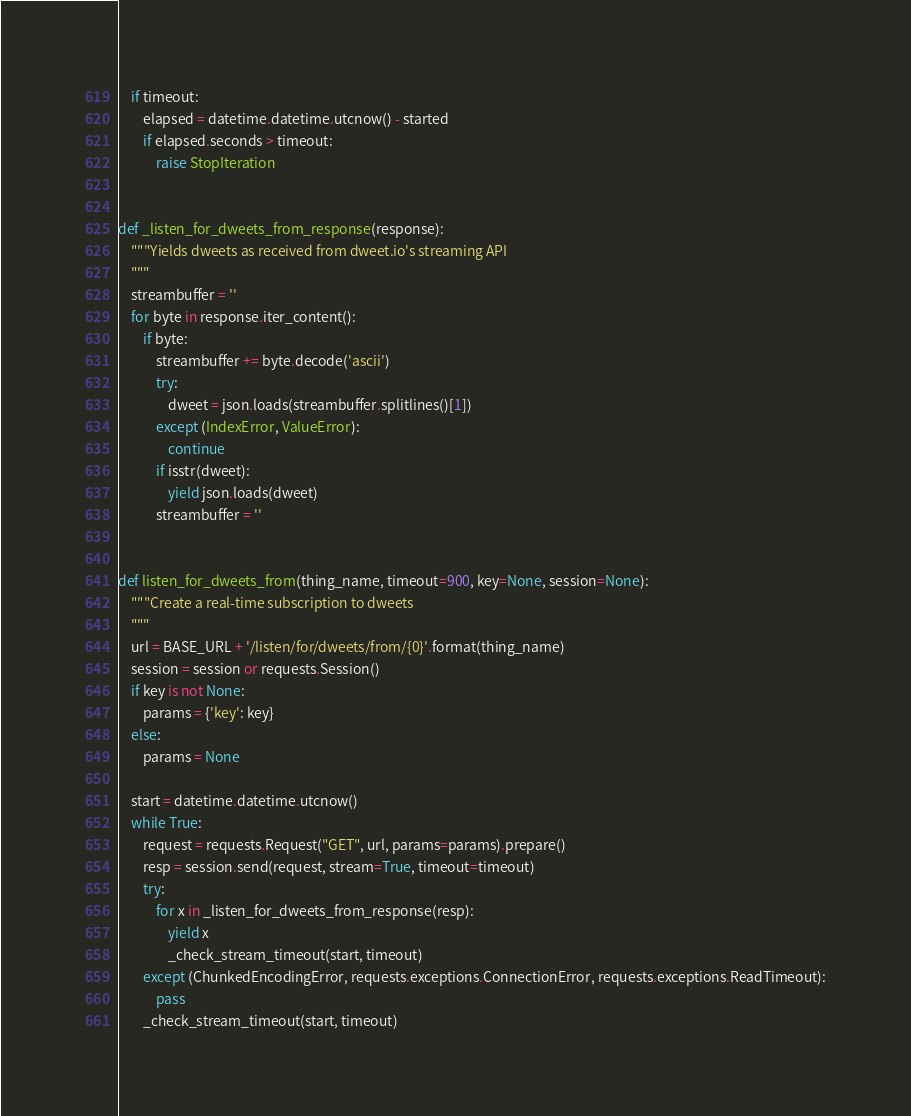Convert code to text. <code><loc_0><loc_0><loc_500><loc_500><_Python_>    if timeout:
        elapsed = datetime.datetime.utcnow() - started
        if elapsed.seconds > timeout:
            raise StopIteration


def _listen_for_dweets_from_response(response):
    """Yields dweets as received from dweet.io's streaming API
    """
    streambuffer = ''
    for byte in response.iter_content():
        if byte:
            streambuffer += byte.decode('ascii')
            try:
                dweet = json.loads(streambuffer.splitlines()[1])
            except (IndexError, ValueError):
                continue
            if isstr(dweet):
                yield json.loads(dweet)
            streambuffer = ''


def listen_for_dweets_from(thing_name, timeout=900, key=None, session=None):
    """Create a real-time subscription to dweets
    """
    url = BASE_URL + '/listen/for/dweets/from/{0}'.format(thing_name)
    session = session or requests.Session()
    if key is not None:
        params = {'key': key}
    else:
        params = None

    start = datetime.datetime.utcnow()
    while True:
        request = requests.Request("GET", url, params=params).prepare()
        resp = session.send(request, stream=True, timeout=timeout)
        try:
            for x in _listen_for_dweets_from_response(resp):
                yield x
                _check_stream_timeout(start, timeout)
        except (ChunkedEncodingError, requests.exceptions.ConnectionError, requests.exceptions.ReadTimeout):
            pass
        _check_stream_timeout(start, timeout)
</code> 